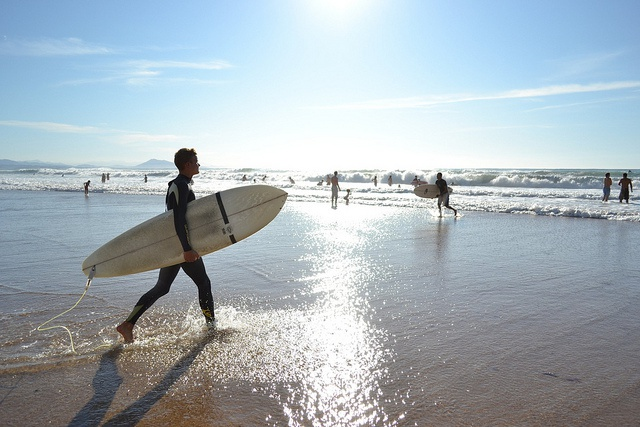Describe the objects in this image and their specific colors. I can see surfboard in darkgray and gray tones, people in darkgray, black, gray, and maroon tones, people in darkgray, white, and gray tones, people in darkgray, black, and gray tones, and people in darkgray, black, gray, and lightgray tones in this image. 